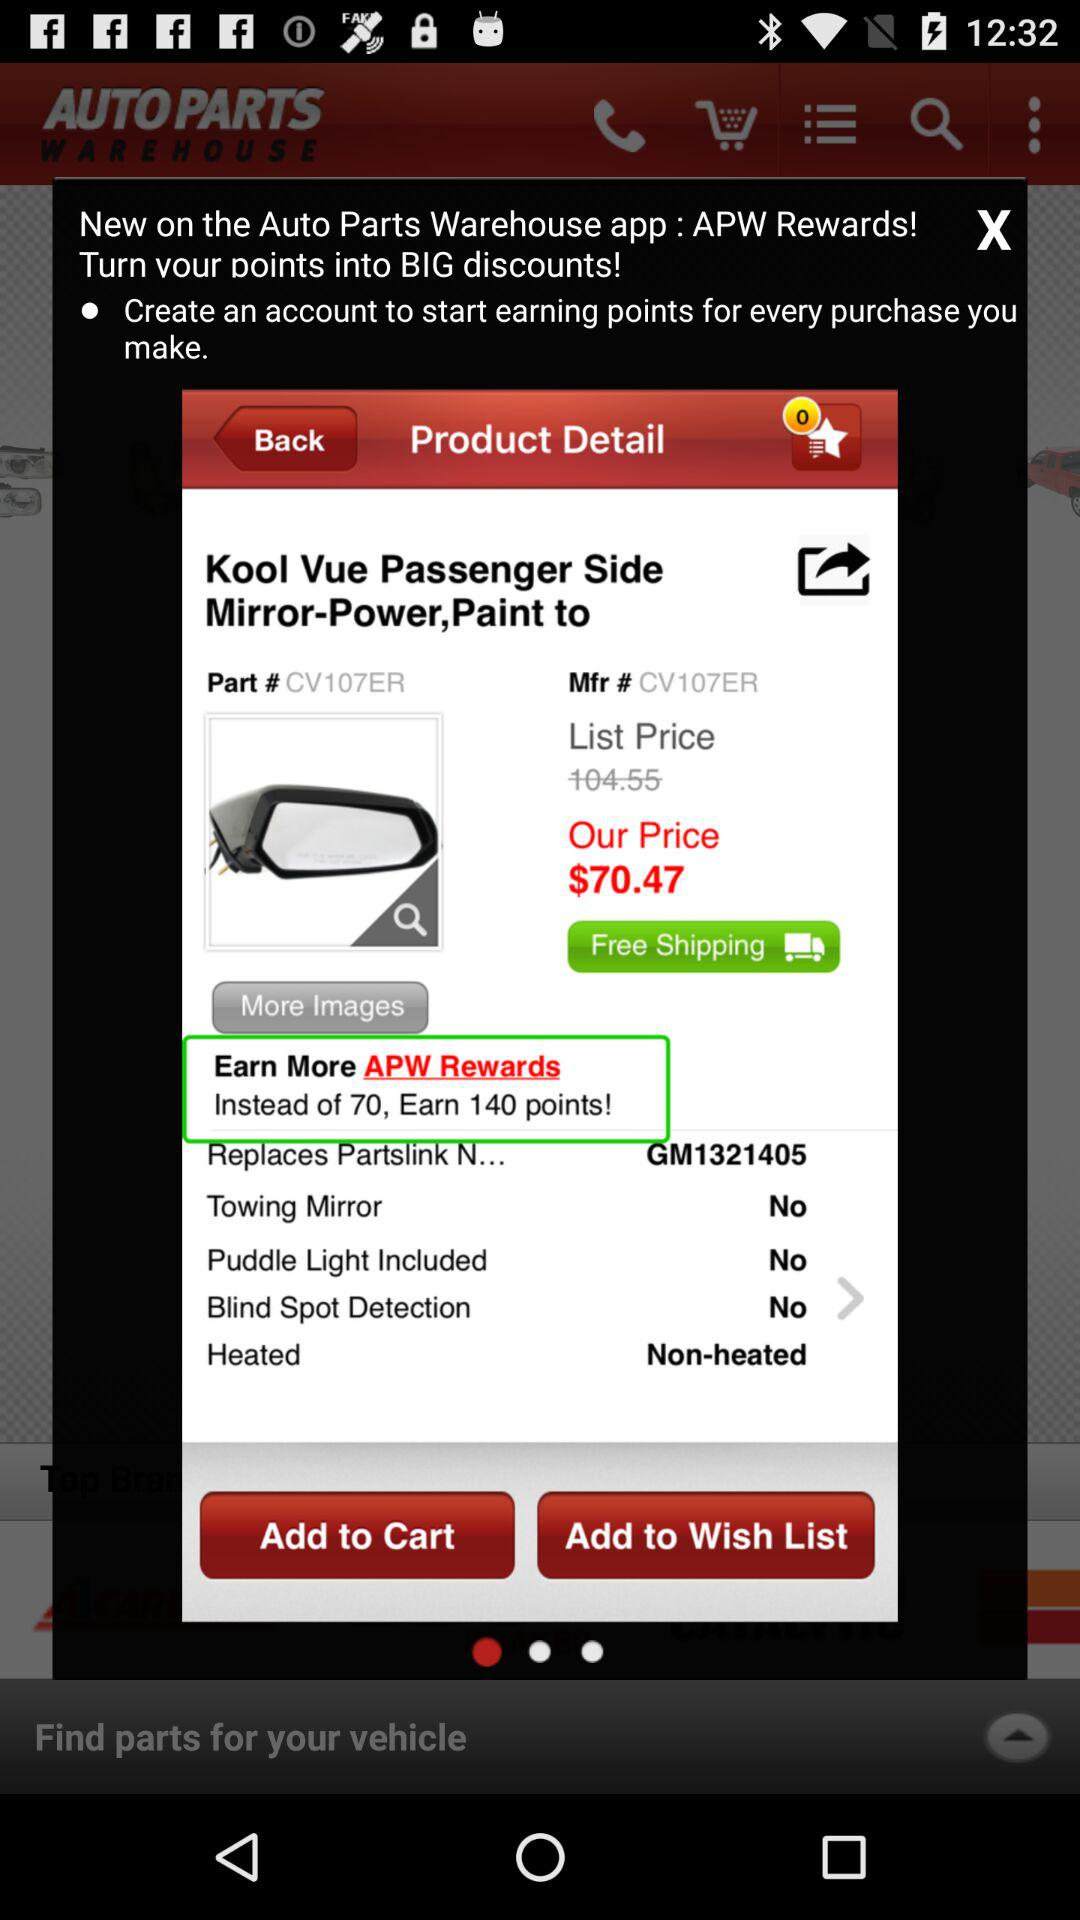What's the price of the product? The price is $70.47. 